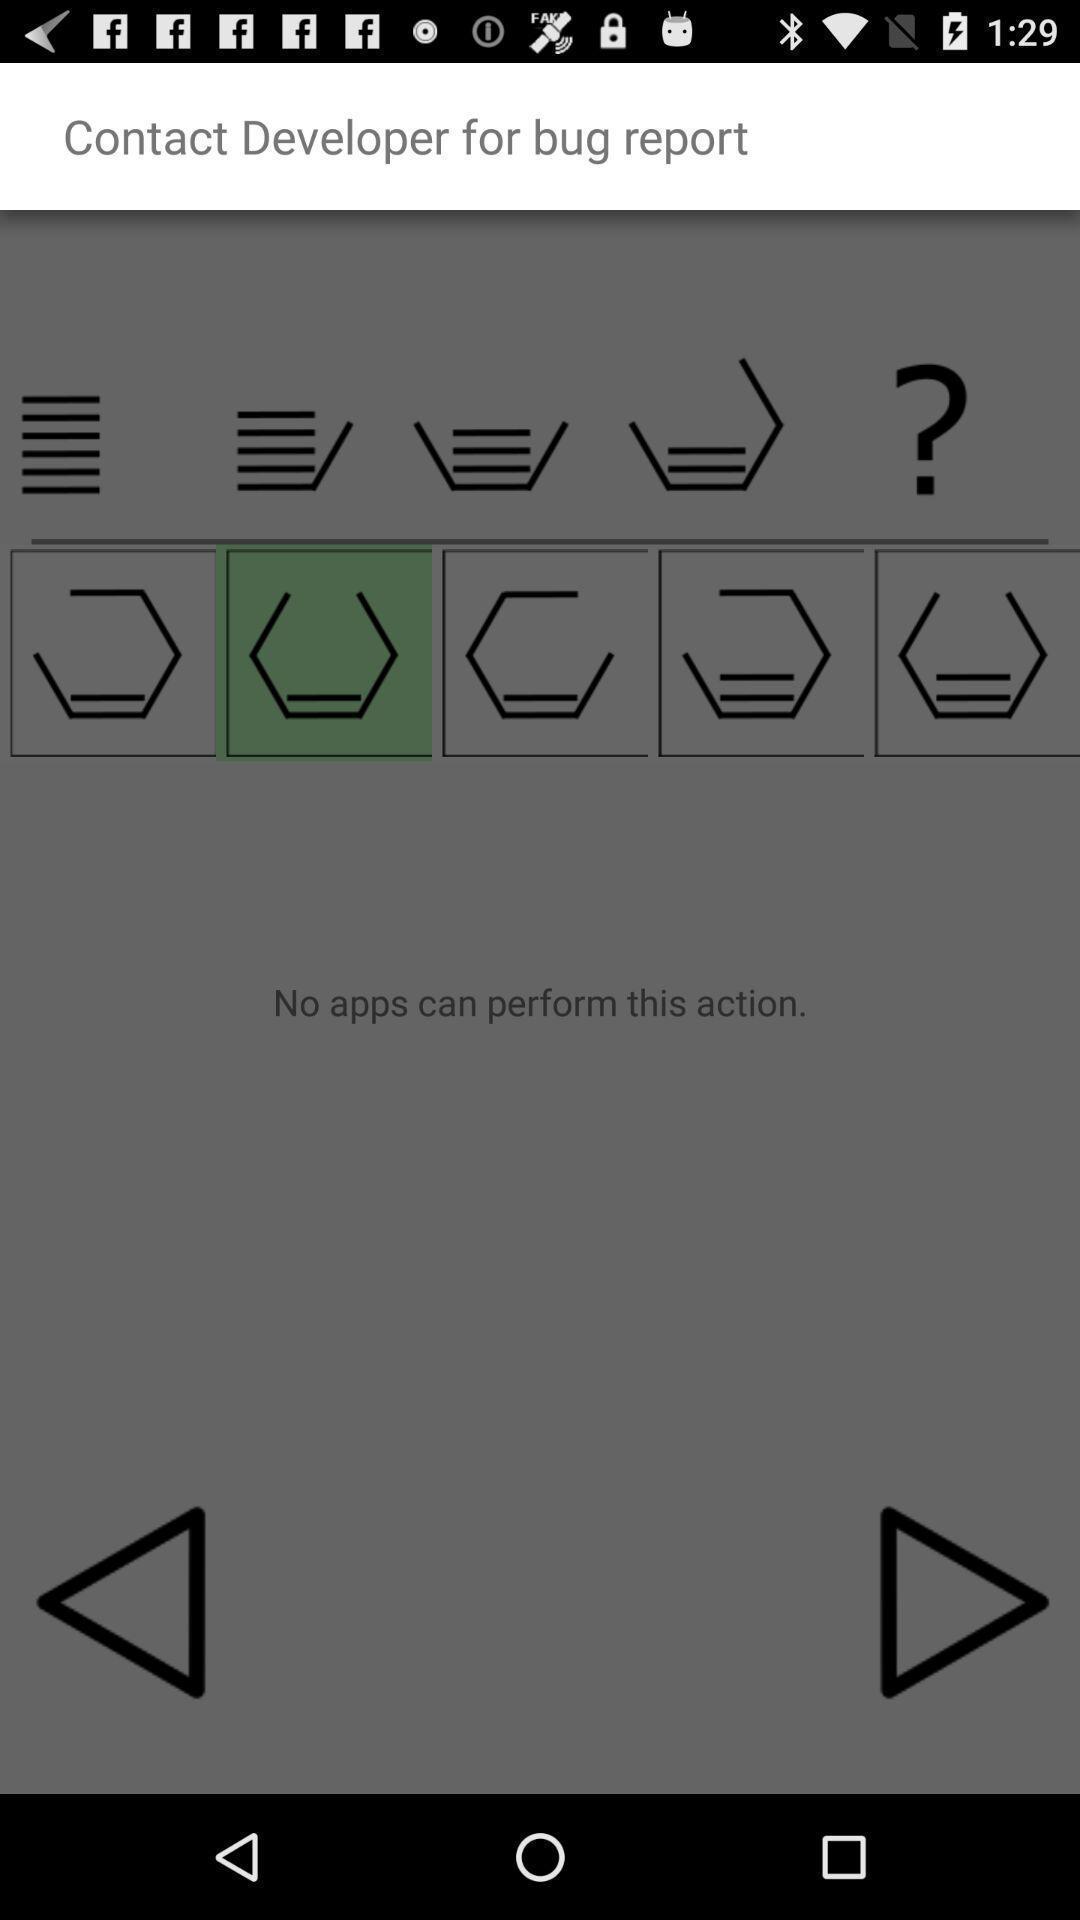What is the overall content of this screenshot? Screen showing various symbols in a job app. 